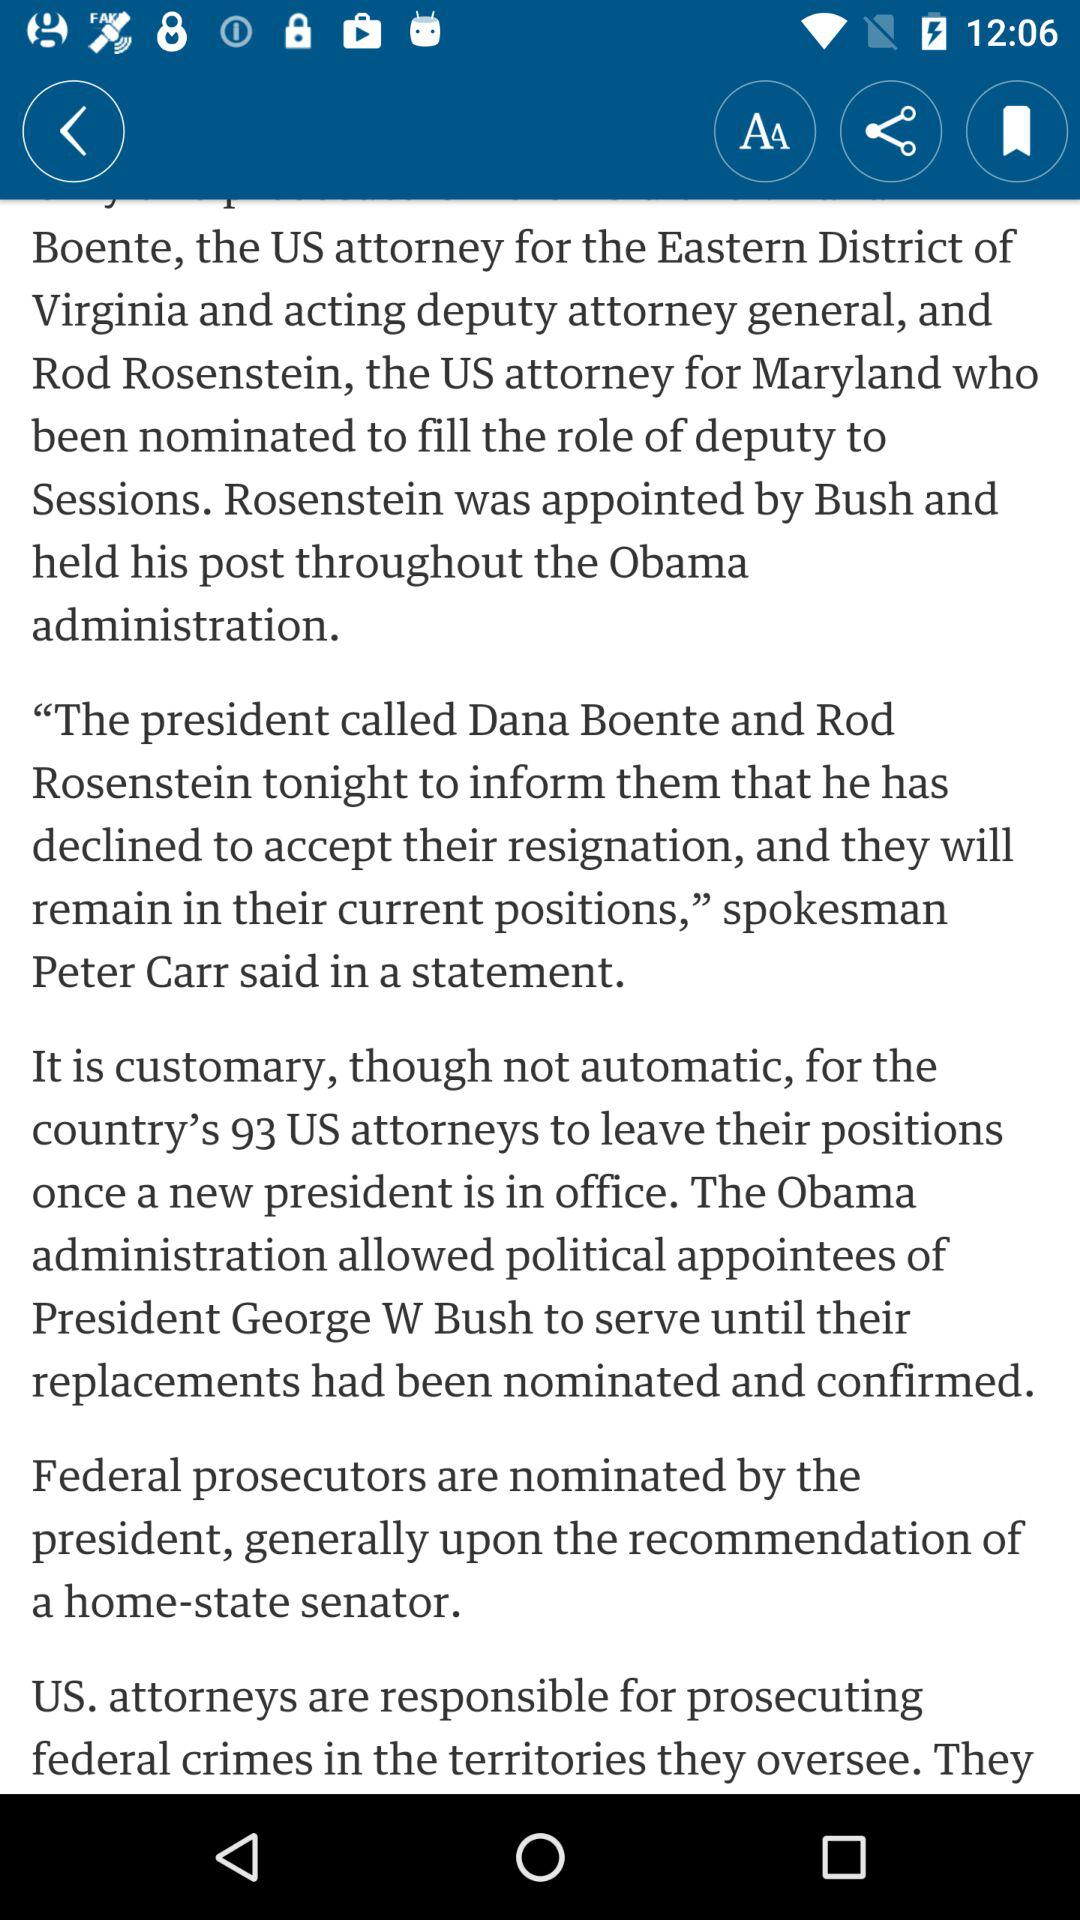How many US attorneys are in the country?
Answer the question using a single word or phrase. 93 